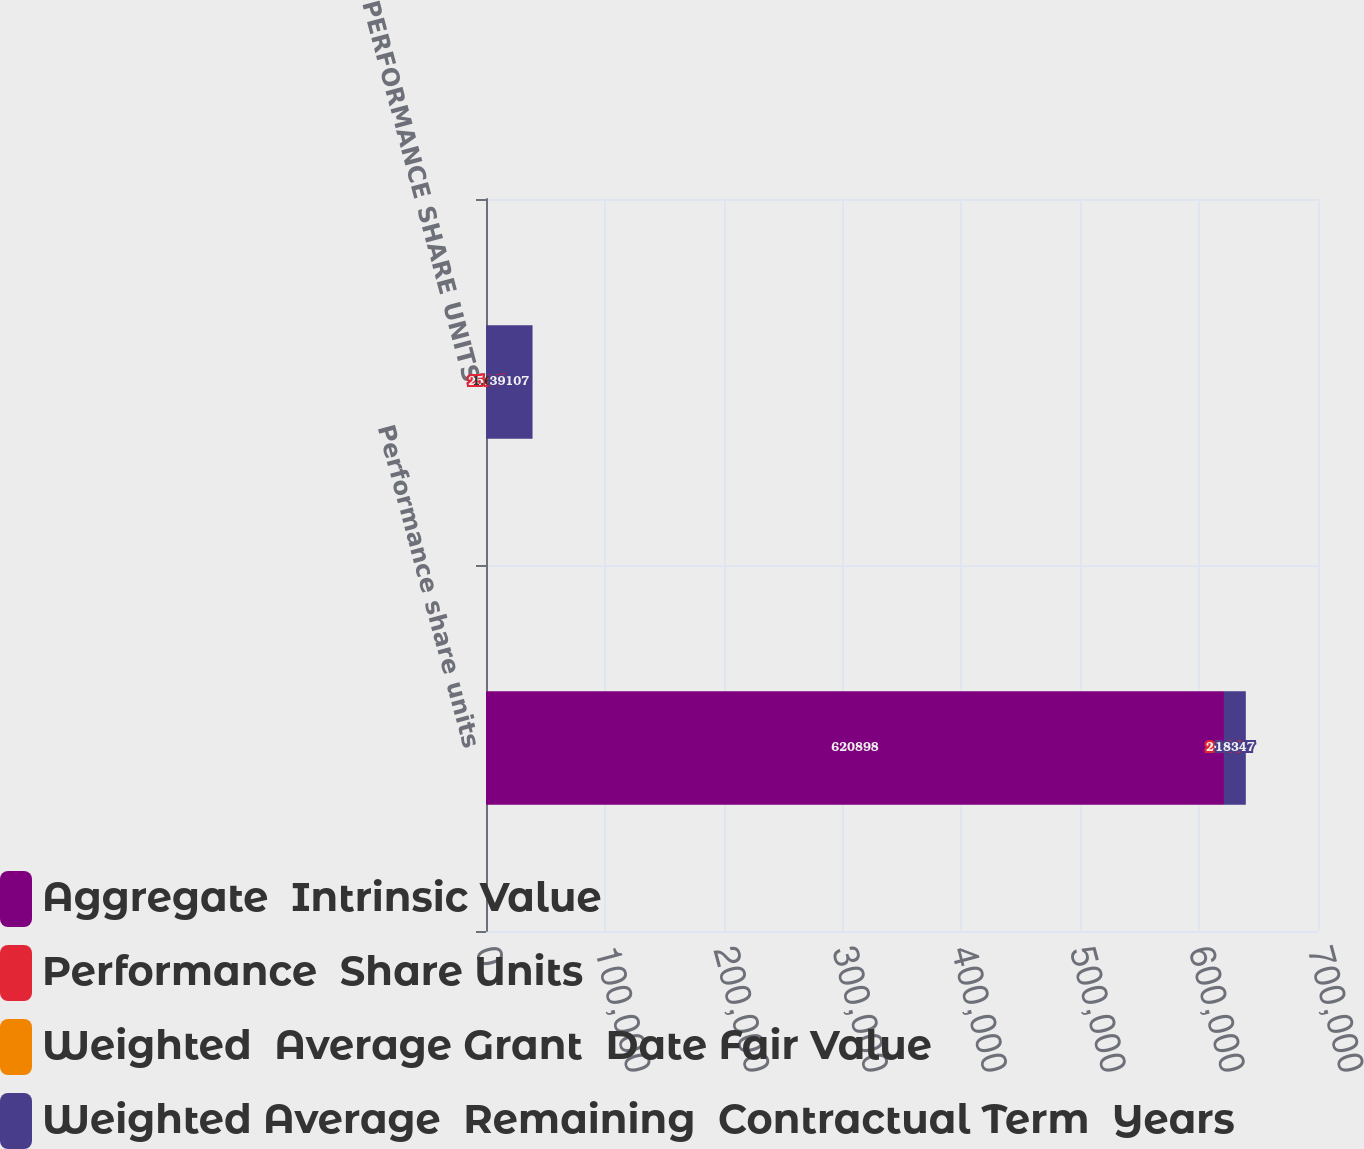Convert chart. <chart><loc_0><loc_0><loc_500><loc_500><stacked_bar_chart><ecel><fcel>Performance share units<fcel>PERFORMANCE SHARE UNITS<nl><fcel>Aggregate  Intrinsic Value<fcel>620898<fcel>25.65<nl><fcel>Performance  Share Units<fcel>20.39<fcel>25.65<nl><fcel>Weighted  Average Grant  Date Fair Value<fcel>2.2<fcel>1.61<nl><fcel>Weighted Average  Remaining  Contractual Term  Years<fcel>18347<fcel>39107<nl></chart> 